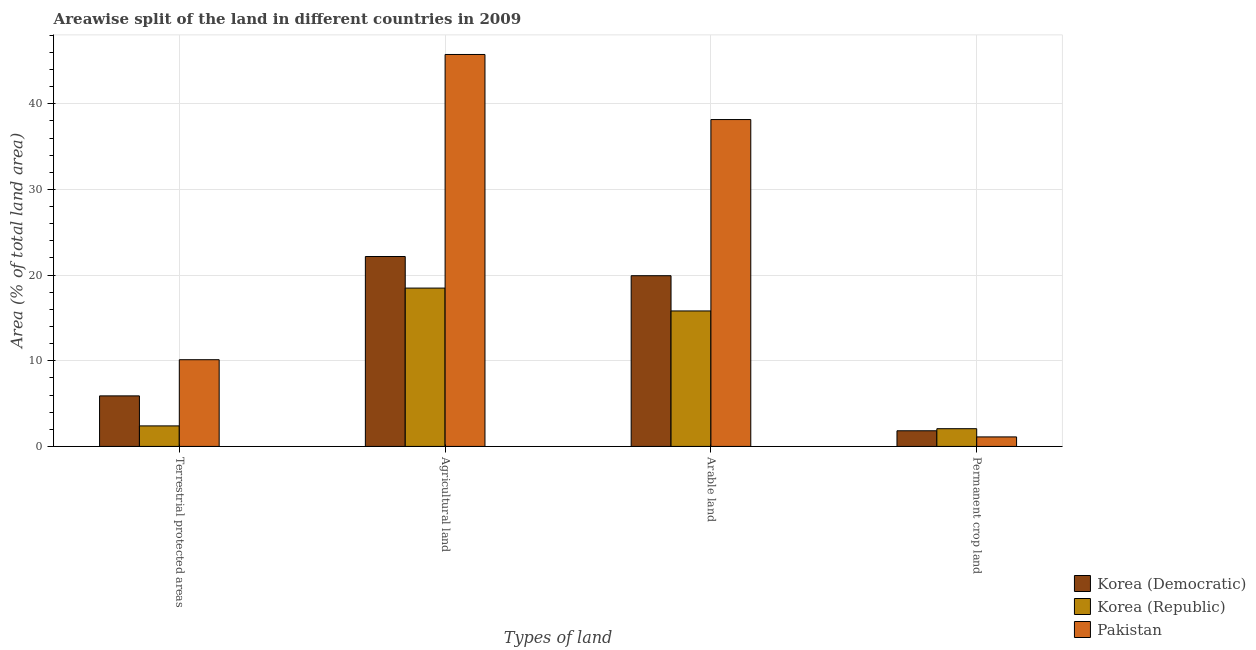How many different coloured bars are there?
Ensure brevity in your answer.  3. How many groups of bars are there?
Keep it short and to the point. 4. Are the number of bars on each tick of the X-axis equal?
Give a very brief answer. Yes. How many bars are there on the 1st tick from the left?
Your answer should be very brief. 3. What is the label of the 2nd group of bars from the left?
Offer a very short reply. Agricultural land. What is the percentage of area under permanent crop land in Korea (Republic)?
Your answer should be very brief. 2.07. Across all countries, what is the maximum percentage of area under arable land?
Ensure brevity in your answer.  38.16. Across all countries, what is the minimum percentage of area under arable land?
Offer a terse response. 15.82. In which country was the percentage of area under permanent crop land maximum?
Your response must be concise. Korea (Republic). In which country was the percentage of area under agricultural land minimum?
Give a very brief answer. Korea (Republic). What is the total percentage of area under arable land in the graph?
Ensure brevity in your answer.  73.91. What is the difference between the percentage of area under arable land in Korea (Democratic) and that in Korea (Republic)?
Your answer should be compact. 4.11. What is the difference between the percentage of area under agricultural land in Korea (Republic) and the percentage of land under terrestrial protection in Korea (Democratic)?
Make the answer very short. 12.58. What is the average percentage of land under terrestrial protection per country?
Keep it short and to the point. 6.14. What is the difference between the percentage of area under permanent crop land and percentage of land under terrestrial protection in Korea (Democratic)?
Give a very brief answer. -4.07. In how many countries, is the percentage of area under permanent crop land greater than 22 %?
Your response must be concise. 0. What is the ratio of the percentage of area under agricultural land in Pakistan to that in Korea (Democratic)?
Offer a very short reply. 2.06. What is the difference between the highest and the second highest percentage of area under arable land?
Offer a very short reply. 18.23. What is the difference between the highest and the lowest percentage of area under agricultural land?
Make the answer very short. 27.28. In how many countries, is the percentage of area under agricultural land greater than the average percentage of area under agricultural land taken over all countries?
Offer a terse response. 1. What does the 1st bar from the left in Agricultural land represents?
Your answer should be compact. Korea (Democratic). What does the 3rd bar from the right in Arable land represents?
Offer a very short reply. Korea (Democratic). Is it the case that in every country, the sum of the percentage of land under terrestrial protection and percentage of area under agricultural land is greater than the percentage of area under arable land?
Ensure brevity in your answer.  Yes. How many bars are there?
Keep it short and to the point. 12. Are all the bars in the graph horizontal?
Ensure brevity in your answer.  No. Does the graph contain any zero values?
Your answer should be compact. No. What is the title of the graph?
Offer a very short reply. Areawise split of the land in different countries in 2009. Does "Greece" appear as one of the legend labels in the graph?
Your answer should be very brief. No. What is the label or title of the X-axis?
Ensure brevity in your answer.  Types of land. What is the label or title of the Y-axis?
Make the answer very short. Area (% of total land area). What is the Area (% of total land area) of Korea (Democratic) in Terrestrial protected areas?
Ensure brevity in your answer.  5.9. What is the Area (% of total land area) of Korea (Republic) in Terrestrial protected areas?
Provide a short and direct response. 2.4. What is the Area (% of total land area) of Pakistan in Terrestrial protected areas?
Make the answer very short. 10.13. What is the Area (% of total land area) of Korea (Democratic) in Agricultural land?
Your response must be concise. 22.17. What is the Area (% of total land area) of Korea (Republic) in Agricultural land?
Your answer should be very brief. 18.49. What is the Area (% of total land area) of Pakistan in Agricultural land?
Give a very brief answer. 45.76. What is the Area (% of total land area) in Korea (Democratic) in Arable land?
Your answer should be very brief. 19.93. What is the Area (% of total land area) in Korea (Republic) in Arable land?
Provide a short and direct response. 15.82. What is the Area (% of total land area) of Pakistan in Arable land?
Offer a very short reply. 38.16. What is the Area (% of total land area) in Korea (Democratic) in Permanent crop land?
Provide a succinct answer. 1.83. What is the Area (% of total land area) of Korea (Republic) in Permanent crop land?
Keep it short and to the point. 2.07. What is the Area (% of total land area) in Pakistan in Permanent crop land?
Offer a very short reply. 1.11. Across all Types of land, what is the maximum Area (% of total land area) in Korea (Democratic)?
Make the answer very short. 22.17. Across all Types of land, what is the maximum Area (% of total land area) of Korea (Republic)?
Give a very brief answer. 18.49. Across all Types of land, what is the maximum Area (% of total land area) in Pakistan?
Keep it short and to the point. 45.76. Across all Types of land, what is the minimum Area (% of total land area) of Korea (Democratic)?
Your response must be concise. 1.83. Across all Types of land, what is the minimum Area (% of total land area) of Korea (Republic)?
Your answer should be very brief. 2.07. Across all Types of land, what is the minimum Area (% of total land area) of Pakistan?
Ensure brevity in your answer.  1.11. What is the total Area (% of total land area) of Korea (Democratic) in the graph?
Make the answer very short. 49.83. What is the total Area (% of total land area) in Korea (Republic) in the graph?
Provide a short and direct response. 38.77. What is the total Area (% of total land area) of Pakistan in the graph?
Your answer should be very brief. 95.16. What is the difference between the Area (% of total land area) of Korea (Democratic) in Terrestrial protected areas and that in Agricultural land?
Ensure brevity in your answer.  -16.27. What is the difference between the Area (% of total land area) of Korea (Republic) in Terrestrial protected areas and that in Agricultural land?
Your answer should be compact. -16.09. What is the difference between the Area (% of total land area) in Pakistan in Terrestrial protected areas and that in Agricultural land?
Keep it short and to the point. -35.64. What is the difference between the Area (% of total land area) of Korea (Democratic) in Terrestrial protected areas and that in Arable land?
Your answer should be compact. -14.03. What is the difference between the Area (% of total land area) in Korea (Republic) in Terrestrial protected areas and that in Arable land?
Give a very brief answer. -13.42. What is the difference between the Area (% of total land area) of Pakistan in Terrestrial protected areas and that in Arable land?
Keep it short and to the point. -28.04. What is the difference between the Area (% of total land area) of Korea (Democratic) in Terrestrial protected areas and that in Permanent crop land?
Your answer should be compact. 4.07. What is the difference between the Area (% of total land area) of Korea (Republic) in Terrestrial protected areas and that in Permanent crop land?
Offer a very short reply. 0.33. What is the difference between the Area (% of total land area) in Pakistan in Terrestrial protected areas and that in Permanent crop land?
Your response must be concise. 9.01. What is the difference between the Area (% of total land area) in Korea (Democratic) in Agricultural land and that in Arable land?
Provide a succinct answer. 2.24. What is the difference between the Area (% of total land area) of Korea (Republic) in Agricultural land and that in Arable land?
Ensure brevity in your answer.  2.67. What is the difference between the Area (% of total land area) in Pakistan in Agricultural land and that in Arable land?
Give a very brief answer. 7.6. What is the difference between the Area (% of total land area) of Korea (Democratic) in Agricultural land and that in Permanent crop land?
Your answer should be compact. 20.35. What is the difference between the Area (% of total land area) of Korea (Republic) in Agricultural land and that in Permanent crop land?
Ensure brevity in your answer.  16.42. What is the difference between the Area (% of total land area) in Pakistan in Agricultural land and that in Permanent crop land?
Provide a short and direct response. 44.65. What is the difference between the Area (% of total land area) in Korea (Democratic) in Arable land and that in Permanent crop land?
Offer a very short reply. 18.1. What is the difference between the Area (% of total land area) in Korea (Republic) in Arable land and that in Permanent crop land?
Keep it short and to the point. 13.75. What is the difference between the Area (% of total land area) of Pakistan in Arable land and that in Permanent crop land?
Ensure brevity in your answer.  37.05. What is the difference between the Area (% of total land area) in Korea (Democratic) in Terrestrial protected areas and the Area (% of total land area) in Korea (Republic) in Agricultural land?
Your answer should be compact. -12.58. What is the difference between the Area (% of total land area) in Korea (Democratic) in Terrestrial protected areas and the Area (% of total land area) in Pakistan in Agricultural land?
Your answer should be very brief. -39.86. What is the difference between the Area (% of total land area) of Korea (Republic) in Terrestrial protected areas and the Area (% of total land area) of Pakistan in Agricultural land?
Your answer should be compact. -43.36. What is the difference between the Area (% of total land area) of Korea (Democratic) in Terrestrial protected areas and the Area (% of total land area) of Korea (Republic) in Arable land?
Give a very brief answer. -9.92. What is the difference between the Area (% of total land area) of Korea (Democratic) in Terrestrial protected areas and the Area (% of total land area) of Pakistan in Arable land?
Make the answer very short. -32.26. What is the difference between the Area (% of total land area) of Korea (Republic) in Terrestrial protected areas and the Area (% of total land area) of Pakistan in Arable land?
Provide a short and direct response. -35.77. What is the difference between the Area (% of total land area) of Korea (Democratic) in Terrestrial protected areas and the Area (% of total land area) of Korea (Republic) in Permanent crop land?
Provide a succinct answer. 3.83. What is the difference between the Area (% of total land area) of Korea (Democratic) in Terrestrial protected areas and the Area (% of total land area) of Pakistan in Permanent crop land?
Your response must be concise. 4.79. What is the difference between the Area (% of total land area) in Korea (Republic) in Terrestrial protected areas and the Area (% of total land area) in Pakistan in Permanent crop land?
Offer a very short reply. 1.29. What is the difference between the Area (% of total land area) in Korea (Democratic) in Agricultural land and the Area (% of total land area) in Korea (Republic) in Arable land?
Offer a very short reply. 6.36. What is the difference between the Area (% of total land area) in Korea (Democratic) in Agricultural land and the Area (% of total land area) in Pakistan in Arable land?
Make the answer very short. -15.99. What is the difference between the Area (% of total land area) in Korea (Republic) in Agricultural land and the Area (% of total land area) in Pakistan in Arable land?
Offer a terse response. -19.68. What is the difference between the Area (% of total land area) in Korea (Democratic) in Agricultural land and the Area (% of total land area) in Korea (Republic) in Permanent crop land?
Your answer should be compact. 20.1. What is the difference between the Area (% of total land area) in Korea (Democratic) in Agricultural land and the Area (% of total land area) in Pakistan in Permanent crop land?
Your response must be concise. 21.06. What is the difference between the Area (% of total land area) of Korea (Republic) in Agricultural land and the Area (% of total land area) of Pakistan in Permanent crop land?
Your response must be concise. 17.37. What is the difference between the Area (% of total land area) in Korea (Democratic) in Arable land and the Area (% of total land area) in Korea (Republic) in Permanent crop land?
Give a very brief answer. 17.86. What is the difference between the Area (% of total land area) in Korea (Democratic) in Arable land and the Area (% of total land area) in Pakistan in Permanent crop land?
Your answer should be compact. 18.82. What is the difference between the Area (% of total land area) of Korea (Republic) in Arable land and the Area (% of total land area) of Pakistan in Permanent crop land?
Make the answer very short. 14.71. What is the average Area (% of total land area) of Korea (Democratic) per Types of land?
Your answer should be compact. 12.46. What is the average Area (% of total land area) in Korea (Republic) per Types of land?
Provide a succinct answer. 9.69. What is the average Area (% of total land area) in Pakistan per Types of land?
Offer a very short reply. 23.79. What is the difference between the Area (% of total land area) in Korea (Democratic) and Area (% of total land area) in Korea (Republic) in Terrestrial protected areas?
Offer a terse response. 3.5. What is the difference between the Area (% of total land area) in Korea (Democratic) and Area (% of total land area) in Pakistan in Terrestrial protected areas?
Give a very brief answer. -4.22. What is the difference between the Area (% of total land area) of Korea (Republic) and Area (% of total land area) of Pakistan in Terrestrial protected areas?
Offer a very short reply. -7.73. What is the difference between the Area (% of total land area) in Korea (Democratic) and Area (% of total land area) in Korea (Republic) in Agricultural land?
Offer a very short reply. 3.69. What is the difference between the Area (% of total land area) in Korea (Democratic) and Area (% of total land area) in Pakistan in Agricultural land?
Keep it short and to the point. -23.59. What is the difference between the Area (% of total land area) in Korea (Republic) and Area (% of total land area) in Pakistan in Agricultural land?
Your response must be concise. -27.28. What is the difference between the Area (% of total land area) of Korea (Democratic) and Area (% of total land area) of Korea (Republic) in Arable land?
Provide a succinct answer. 4.11. What is the difference between the Area (% of total land area) in Korea (Democratic) and Area (% of total land area) in Pakistan in Arable land?
Give a very brief answer. -18.23. What is the difference between the Area (% of total land area) of Korea (Republic) and Area (% of total land area) of Pakistan in Arable land?
Offer a terse response. -22.35. What is the difference between the Area (% of total land area) of Korea (Democratic) and Area (% of total land area) of Korea (Republic) in Permanent crop land?
Offer a very short reply. -0.24. What is the difference between the Area (% of total land area) of Korea (Democratic) and Area (% of total land area) of Pakistan in Permanent crop land?
Your answer should be compact. 0.72. What is the ratio of the Area (% of total land area) of Korea (Democratic) in Terrestrial protected areas to that in Agricultural land?
Provide a short and direct response. 0.27. What is the ratio of the Area (% of total land area) in Korea (Republic) in Terrestrial protected areas to that in Agricultural land?
Offer a terse response. 0.13. What is the ratio of the Area (% of total land area) in Pakistan in Terrestrial protected areas to that in Agricultural land?
Make the answer very short. 0.22. What is the ratio of the Area (% of total land area) of Korea (Democratic) in Terrestrial protected areas to that in Arable land?
Ensure brevity in your answer.  0.3. What is the ratio of the Area (% of total land area) in Korea (Republic) in Terrestrial protected areas to that in Arable land?
Your answer should be very brief. 0.15. What is the ratio of the Area (% of total land area) of Pakistan in Terrestrial protected areas to that in Arable land?
Give a very brief answer. 0.27. What is the ratio of the Area (% of total land area) in Korea (Democratic) in Terrestrial protected areas to that in Permanent crop land?
Offer a very short reply. 3.23. What is the ratio of the Area (% of total land area) of Korea (Republic) in Terrestrial protected areas to that in Permanent crop land?
Provide a short and direct response. 1.16. What is the ratio of the Area (% of total land area) in Pakistan in Terrestrial protected areas to that in Permanent crop land?
Ensure brevity in your answer.  9.11. What is the ratio of the Area (% of total land area) of Korea (Democratic) in Agricultural land to that in Arable land?
Give a very brief answer. 1.11. What is the ratio of the Area (% of total land area) in Korea (Republic) in Agricultural land to that in Arable land?
Your response must be concise. 1.17. What is the ratio of the Area (% of total land area) in Pakistan in Agricultural land to that in Arable land?
Provide a short and direct response. 1.2. What is the ratio of the Area (% of total land area) of Korea (Democratic) in Agricultural land to that in Permanent crop land?
Offer a terse response. 12.14. What is the ratio of the Area (% of total land area) in Korea (Republic) in Agricultural land to that in Permanent crop land?
Make the answer very short. 8.93. What is the ratio of the Area (% of total land area) of Pakistan in Agricultural land to that in Permanent crop land?
Offer a very short reply. 41.16. What is the ratio of the Area (% of total land area) of Korea (Democratic) in Arable land to that in Permanent crop land?
Offer a very short reply. 10.91. What is the ratio of the Area (% of total land area) in Korea (Republic) in Arable land to that in Permanent crop land?
Provide a succinct answer. 7.64. What is the ratio of the Area (% of total land area) in Pakistan in Arable land to that in Permanent crop land?
Give a very brief answer. 34.33. What is the difference between the highest and the second highest Area (% of total land area) of Korea (Democratic)?
Offer a terse response. 2.24. What is the difference between the highest and the second highest Area (% of total land area) in Korea (Republic)?
Keep it short and to the point. 2.67. What is the difference between the highest and the second highest Area (% of total land area) in Pakistan?
Offer a very short reply. 7.6. What is the difference between the highest and the lowest Area (% of total land area) of Korea (Democratic)?
Provide a succinct answer. 20.35. What is the difference between the highest and the lowest Area (% of total land area) of Korea (Republic)?
Offer a very short reply. 16.42. What is the difference between the highest and the lowest Area (% of total land area) in Pakistan?
Make the answer very short. 44.65. 